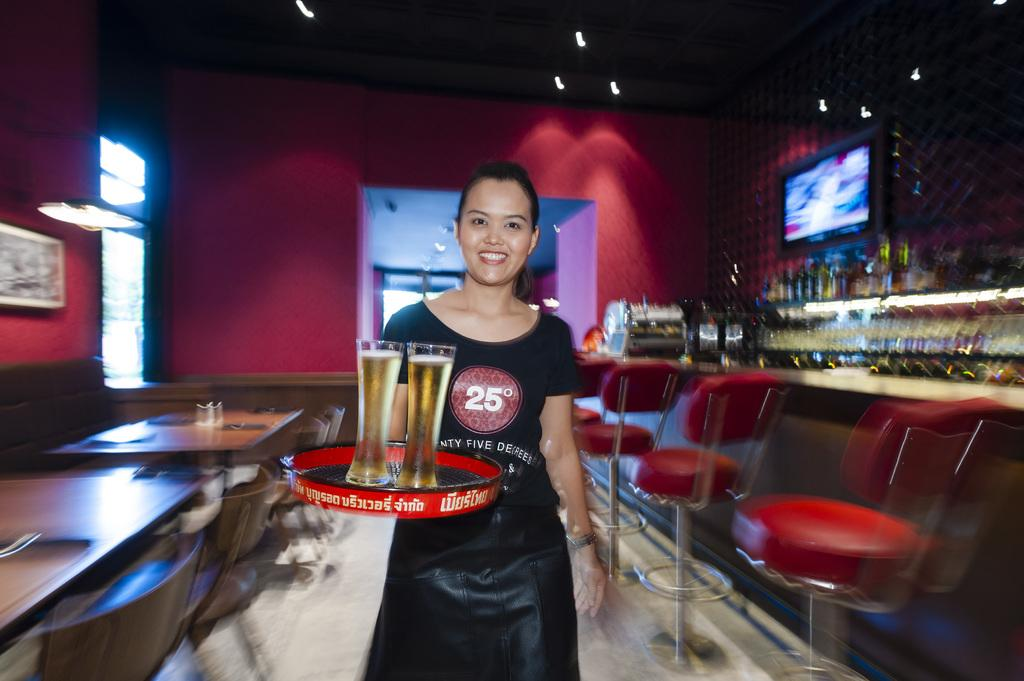What is the main subject of the image? The main subject of the image is a woman. What is the woman doing in the image? The woman is standing and holding wine glasses in a tray. What other objects can be seen in the image? There is a television, chairs, and tables in the image. How many bombs are visible in the image? There are no bombs present in the image. What type of sorting is the woman performing with the wine glasses? The woman is not performing any sorting with the wine glasses; she is simply holding them in a tray. 